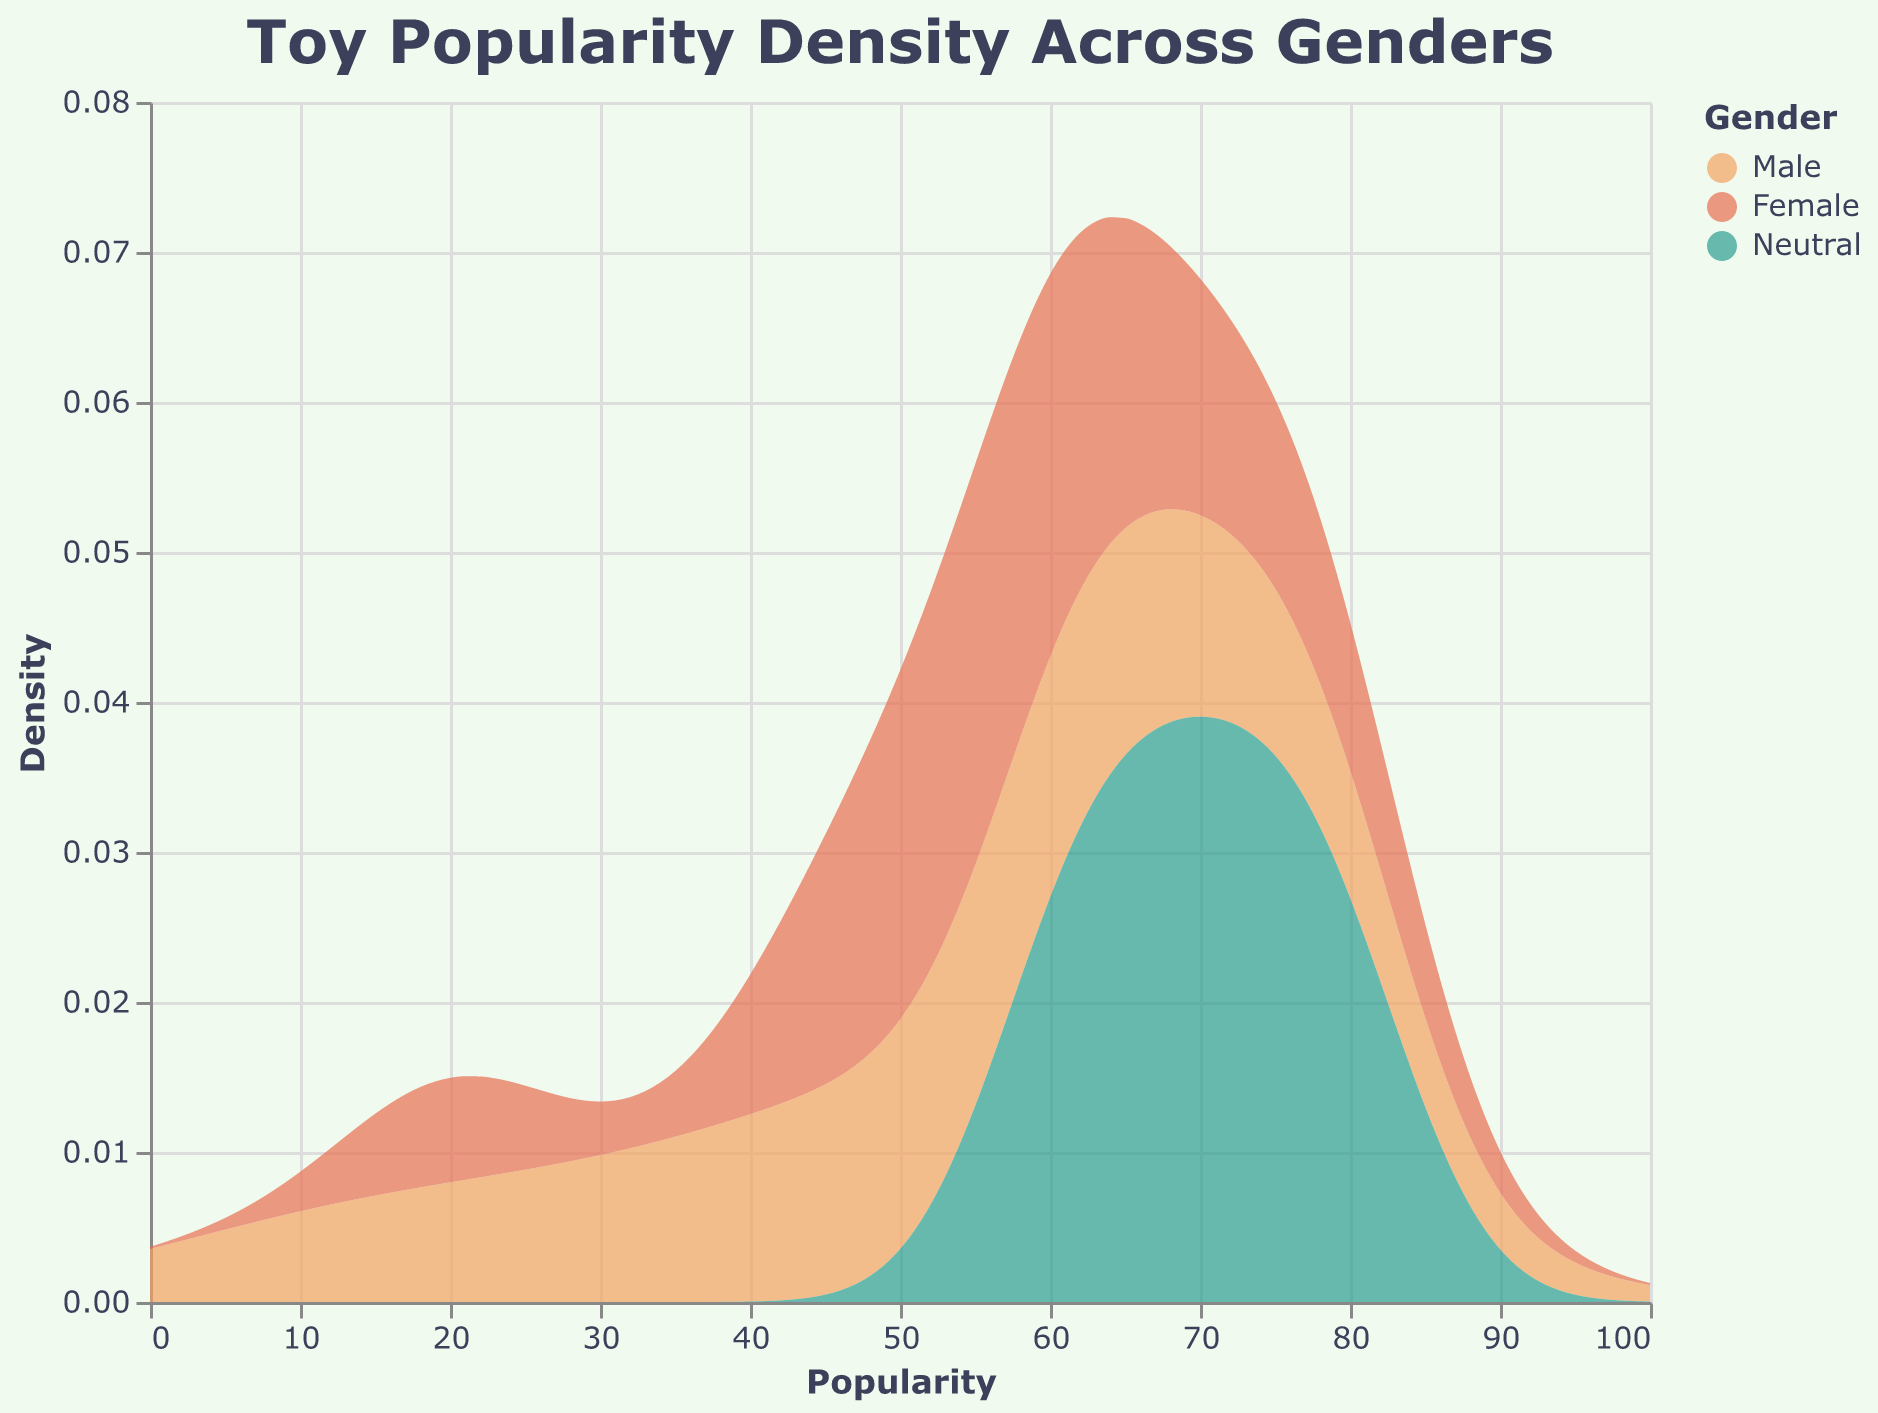What is the title of the plot? The title is located at the top of the plot. It is a textual element that usually describes the main content of the figure.
Answer: Toy Popularity Density Across Genders What does the x-axis represent in this plot? The x-axis is annotated with labels and a title. It usually represents the variable against which the density is plotted.
Answer: Popularity How are the genders represented by colors in the plot? The plot legend shows how the colors correspond to different genders, with each color representing a specific gender.
Answer: Male is orange, Female is red, Neutral is green Which gender has the highest density for toy popularity around the value of 75? Identify the peak of each density curve near the value of 75 on the x-axis and determine which is the highest.
Answer: Neutral What is the relationship between the popularity of 'Dolls' and gender? Refer to the plot and locate the data density for 'Dolls' for each gender, then compare their popularity values.
Answer: Dolls are most popular among Females Which toy category shows the most balanced popularity across genders? Examine the density distributions of each toy category for different genders and identify the category with the most even spread.
Answer: Board Games Is there a significant difference in toy popularity between Male and Female for 'Legos'? Compare the peaks of the density curves for Male and Female around the specific popularity values for 'Legos'.
Answer: Yes, Males have higher density for 'Legos' What can be inferred about the popularity of 'Educational Toys' across different genders? Look at the density curves associated with 'Educational Toys' across all three genders and note any major differences or similarities.
Answer: Educational Toys are most popular across all genders, especially Neutral Which gender shows the least variation in toy popularity based on the density curves? Identify which gender has the most narrow and consistent density curves across the popularity values.
Answer: Female How does the popularity of 'Outdoor Toys' compare between genders? Examine the density curves corresponding to 'Outdoor Toys' and compare their peaks and spread for different genders.
Answer: Outdoor Toys are most popular among Males and Neutral 